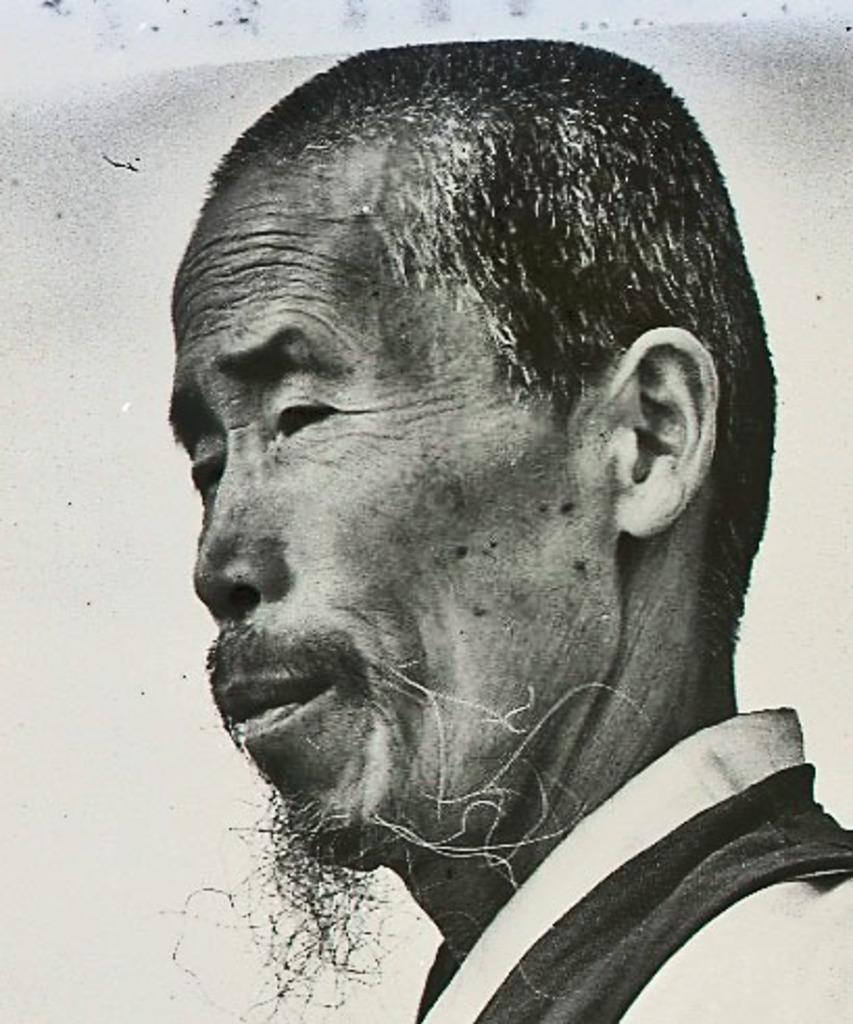What is the color scheme of the image? The image is black and white. Who is present in the image? There is a man in the image. What is the man wearing? The man is wearing a dress. What type of amusement can be seen in the image? There is no amusement present in the image; it features a man wearing a dress in a black and white setting. What kind of advice is the man giving in the image? There is no indication in the image that the man is giving any advice. 